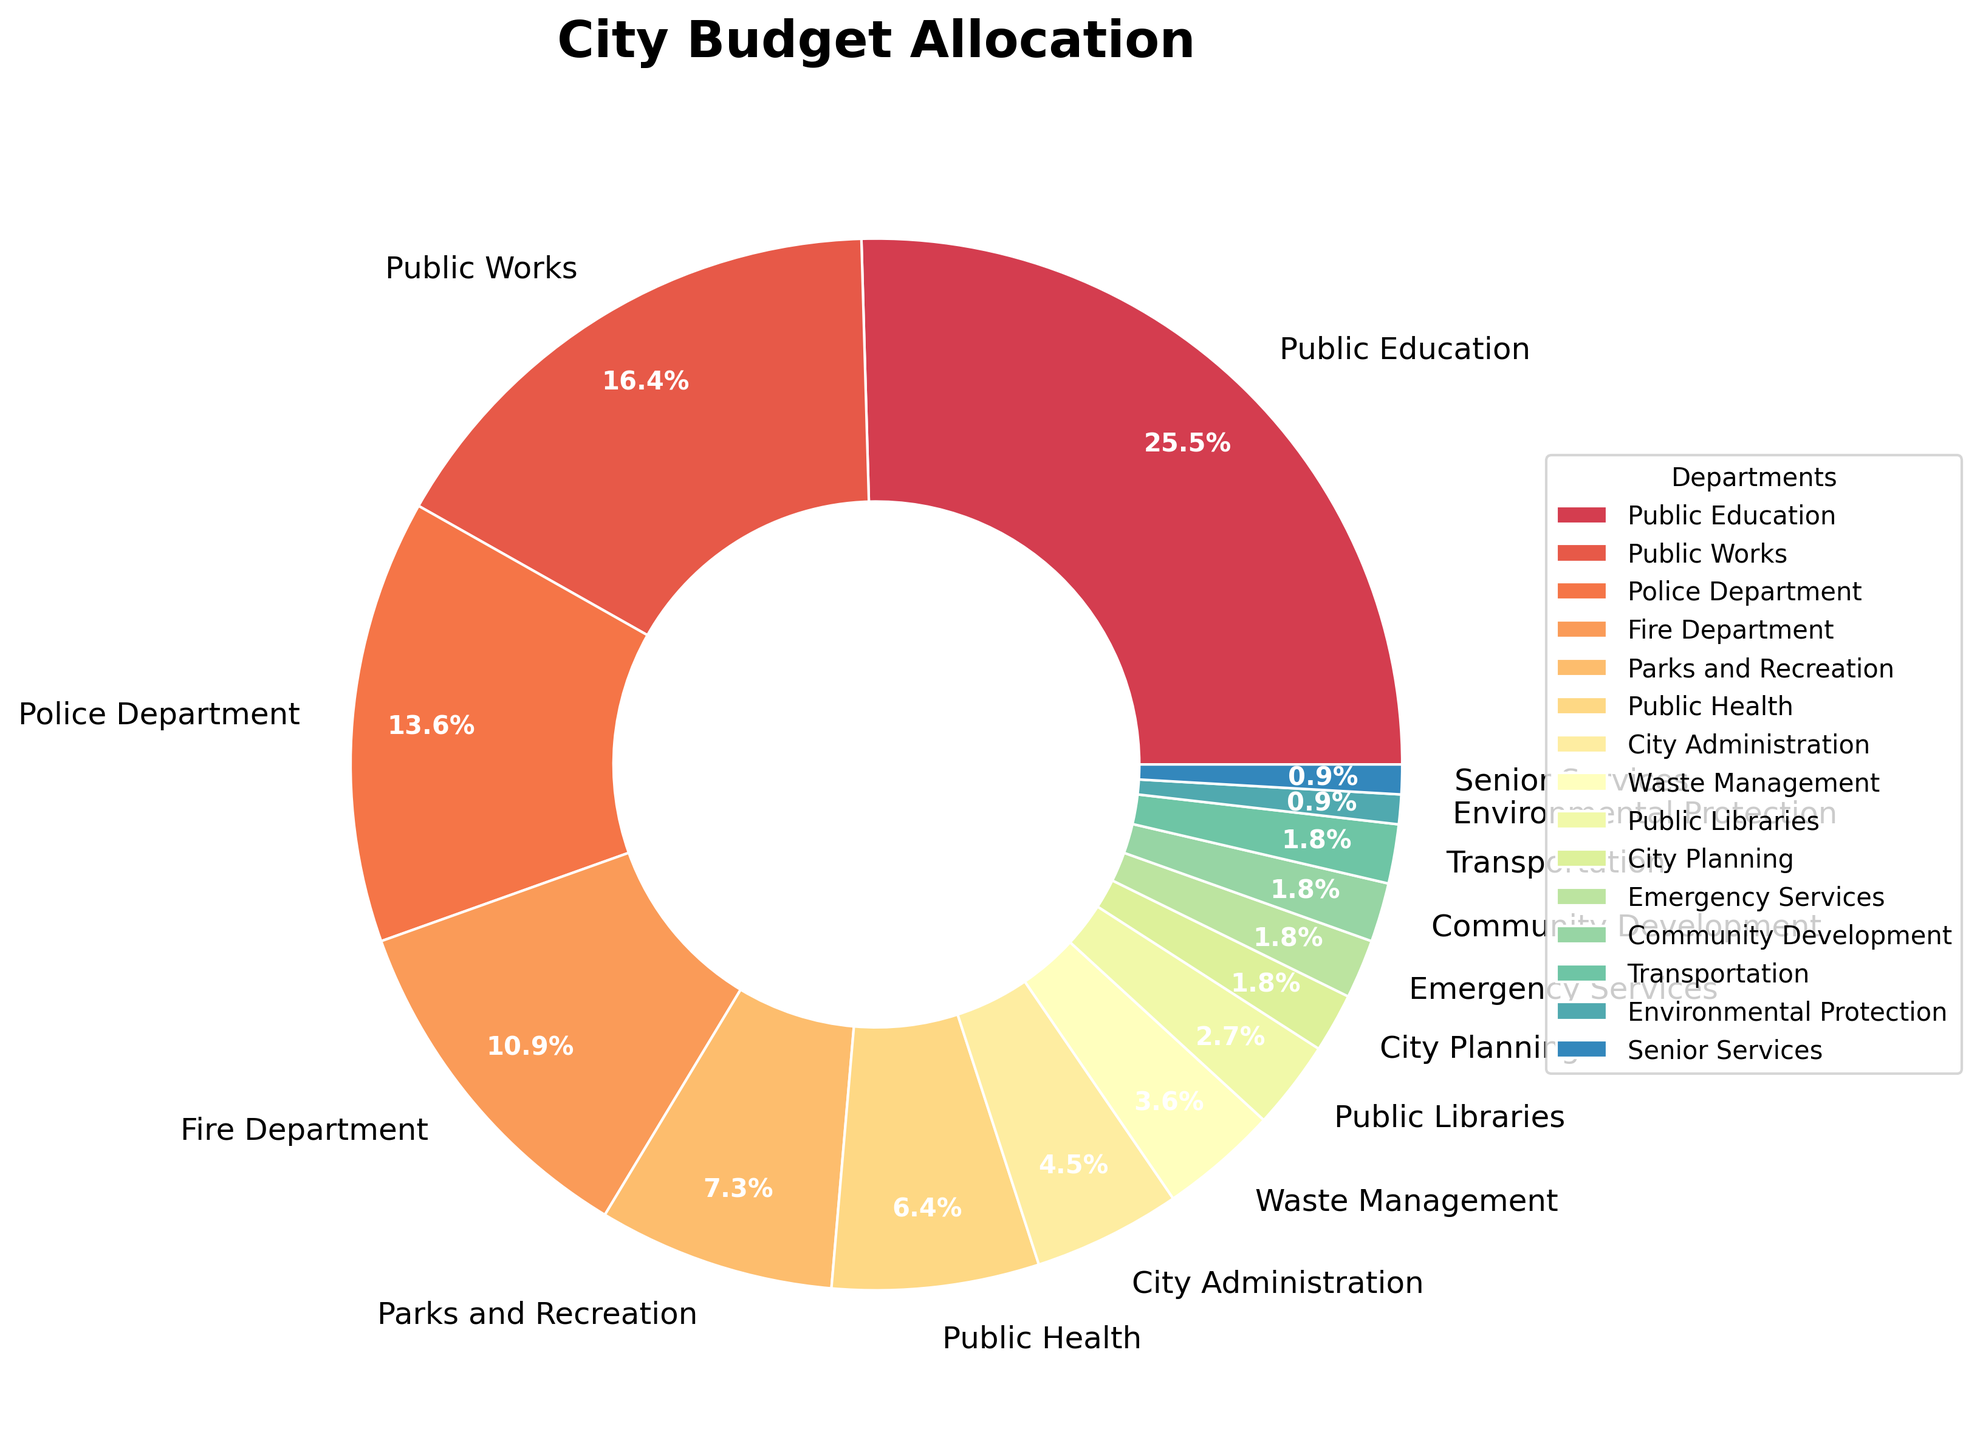What is the total percentage allocated to emergency-related departments (Police Department, Fire Department, Emergency Services)? The emergency-related departments are the Police Department, Fire Department, and Emergency Services. Summing up their budget allocations: 15% + 12% + 2% = 29%.
Answer: 29% Which department receives the highest allocation in the city budget? From the pie chart, the department with the largest segment or slice is Public Education, which is labeled as receiving 28%.
Answer: Public Education How much more budget allocation does Public Works receive compared to Parks and Recreation? The budget allocation for Public Works is 18%, while for Parks and Recreation, it is 8%. The difference between them is 18% - 8% = 10%.
Answer: 10% Do City Administration and Waste Management combined receive a higher percentage than Public Health? City Administration has 5% and Waste Management has 4%. Combined, they total 5% + 4% = 9%. Public Health has 7%, so 9% is greater than 7%.
Answer: Yes What is the combined allocation for departments that receive 2% each? The departments with a 2% allocation are City Planning, Emergency Services, Community Development, and Transportation. Summing them gives 2% + 2% + 2% + 2% = 8%.
Answer: 8% Which department has a smaller budget allocation, Environmental Protection or Senior Services? Both Environmental Protection and Senior Services have the same percentage allocation, which is 1%.
Answer: Equal What is the collective percentage allocated to Public Health, City Administration, and Public Libraries? The allocations are 7% for Public Health, 5% for City Administration, and 3% for Public Libraries. Adding them together, 7% + 5% + 3% = 15%.
Answer: 15% How many departments have an allocation greater than or equal to 10%? By looking at the percentages, the departments with an allocation of 10% or more are Public Education (28%), Public Works (18%), Police Department (15%), and Fire Department (12%). There are 4 such departments.
Answer: 4 When comparing Public Libraries and Transportation, which department has a higher allocation and by how much? Public Libraries have an allocation of 3%, while Transportation has an allocation of 2%. The difference is 3% - 2% = 1%.
Answer: Public Libraries by 1% If the city were to cut 1% from each department's budget uniformly, what would be the new allocation for Parks and Recreation? Parks and Recreation currently has an 8% allocation. If 1% is cut uniformly, the new allocation would be 8% - 1% = 7%.
Answer: 7% 